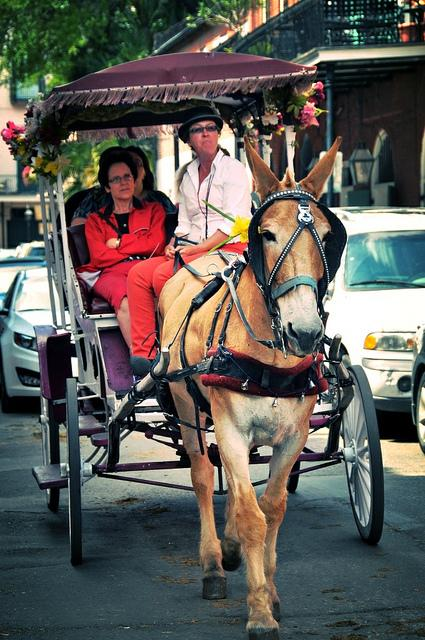What is this horse being used for? Please explain your reasoning. transportation. The horse is pulling a cart carrying a couple. 